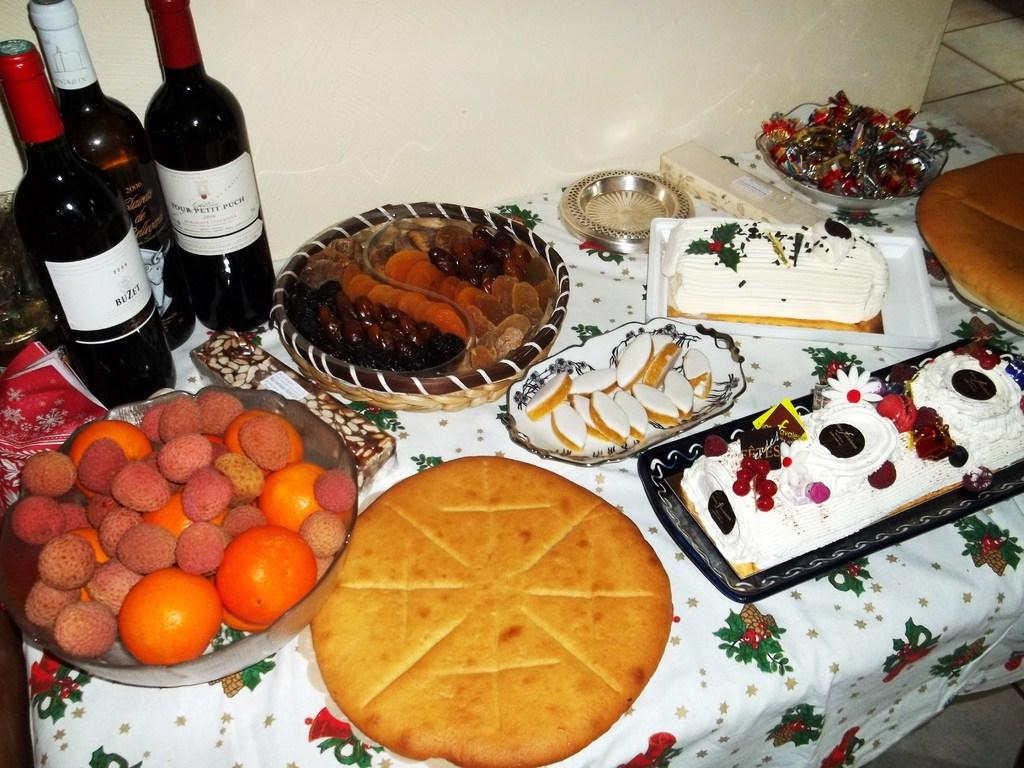What type of containers can be seen on the table in the image? There are bottles on the table in the image. What else is on the table besides the bottles? There is a bowl, trays, a basket, food, cakes, and fruits on the table. What can be found in the bowl? The contents of the bowl are not specified, but it is mentioned that there is food on the table. What type of desserts are present on the table? There are cakes on the table. What type of produce can be seen on the table? There are fruits on the table. What other objects are present on the table? There are various objects on the table, but their specific nature is not mentioned. What is the background of the image? There is a wall and a floor in the image. What type of market is depicted in the image? There is no market present in the image; it features a table with various objects and food items. 